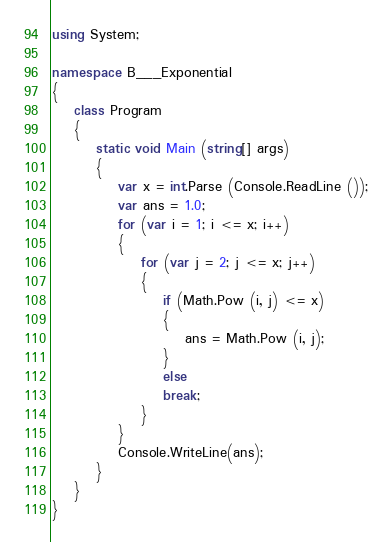Convert code to text. <code><loc_0><loc_0><loc_500><loc_500><_C#_>using System;

namespace B___Exponential
{
    class Program
    {
        static void Main (string[] args)
        {
            var x = int.Parse (Console.ReadLine ());
            var ans = 1.0;
            for (var i = 1; i <= x; i++)
            {
                for (var j = 2; j <= x; j++)
                {
                    if (Math.Pow (i, j) <= x)
                    {
                        ans = Math.Pow (i, j);
                    }
                    else
                    break;
                }
            }
            Console.WriteLine(ans);
        }
    }
}</code> 